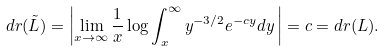Convert formula to latex. <formula><loc_0><loc_0><loc_500><loc_500>d r ( \tilde { L } ) & = \left | \lim _ { x \to \infty } \frac { 1 } { x } \log \int _ { x } ^ { \infty } y ^ { - 3 / 2 } e ^ { - c y } d y \, \right | = c = d r ( L ) .</formula> 